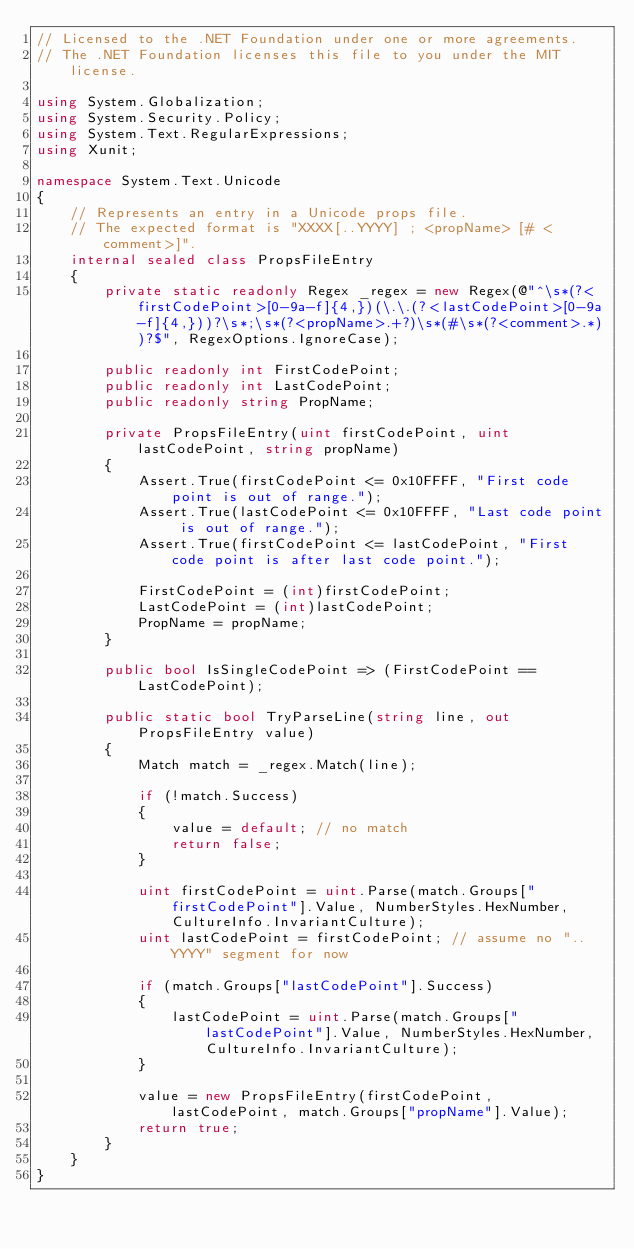<code> <loc_0><loc_0><loc_500><loc_500><_C#_>// Licensed to the .NET Foundation under one or more agreements.
// The .NET Foundation licenses this file to you under the MIT license.

using System.Globalization;
using System.Security.Policy;
using System.Text.RegularExpressions;
using Xunit;

namespace System.Text.Unicode
{
    // Represents an entry in a Unicode props file.
    // The expected format is "XXXX[..YYYY] ; <propName> [# <comment>]".
    internal sealed class PropsFileEntry
    {
        private static readonly Regex _regex = new Regex(@"^\s*(?<firstCodePoint>[0-9a-f]{4,})(\.\.(?<lastCodePoint>[0-9a-f]{4,}))?\s*;\s*(?<propName>.+?)\s*(#\s*(?<comment>.*))?$", RegexOptions.IgnoreCase);

        public readonly int FirstCodePoint;
        public readonly int LastCodePoint;
        public readonly string PropName;

        private PropsFileEntry(uint firstCodePoint, uint lastCodePoint, string propName)
        {
            Assert.True(firstCodePoint <= 0x10FFFF, "First code point is out of range.");
            Assert.True(lastCodePoint <= 0x10FFFF, "Last code point is out of range.");
            Assert.True(firstCodePoint <= lastCodePoint, "First code point is after last code point.");

            FirstCodePoint = (int)firstCodePoint;
            LastCodePoint = (int)lastCodePoint;
            PropName = propName;
        }

        public bool IsSingleCodePoint => (FirstCodePoint == LastCodePoint);

        public static bool TryParseLine(string line, out PropsFileEntry value)
        {
            Match match = _regex.Match(line);

            if (!match.Success)
            {
                value = default; // no match
                return false;
            }

            uint firstCodePoint = uint.Parse(match.Groups["firstCodePoint"].Value, NumberStyles.HexNumber, CultureInfo.InvariantCulture);
            uint lastCodePoint = firstCodePoint; // assume no "..YYYY" segment for now

            if (match.Groups["lastCodePoint"].Success)
            {
                lastCodePoint = uint.Parse(match.Groups["lastCodePoint"].Value, NumberStyles.HexNumber, CultureInfo.InvariantCulture);
            }

            value = new PropsFileEntry(firstCodePoint, lastCodePoint, match.Groups["propName"].Value);
            return true;
        }
    }
}
</code> 